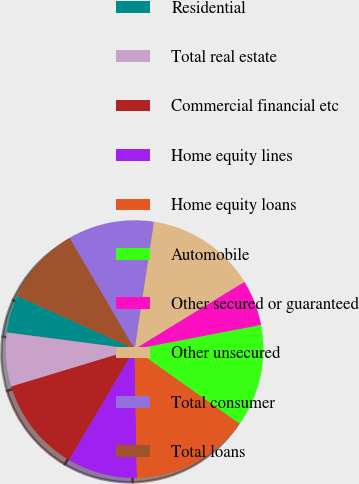<chart> <loc_0><loc_0><loc_500><loc_500><pie_chart><fcel>Residential<fcel>Total real estate<fcel>Commercial financial etc<fcel>Home equity lines<fcel>Home equity loans<fcel>Automobile<fcel>Other secured or guaranteed<fcel>Other unsecured<fcel>Total consumer<fcel>Total loans<nl><fcel>4.72%<fcel>6.75%<fcel>11.83%<fcel>8.78%<fcel>14.88%<fcel>12.84%<fcel>5.73%<fcel>13.86%<fcel>10.81%<fcel>9.8%<nl></chart> 